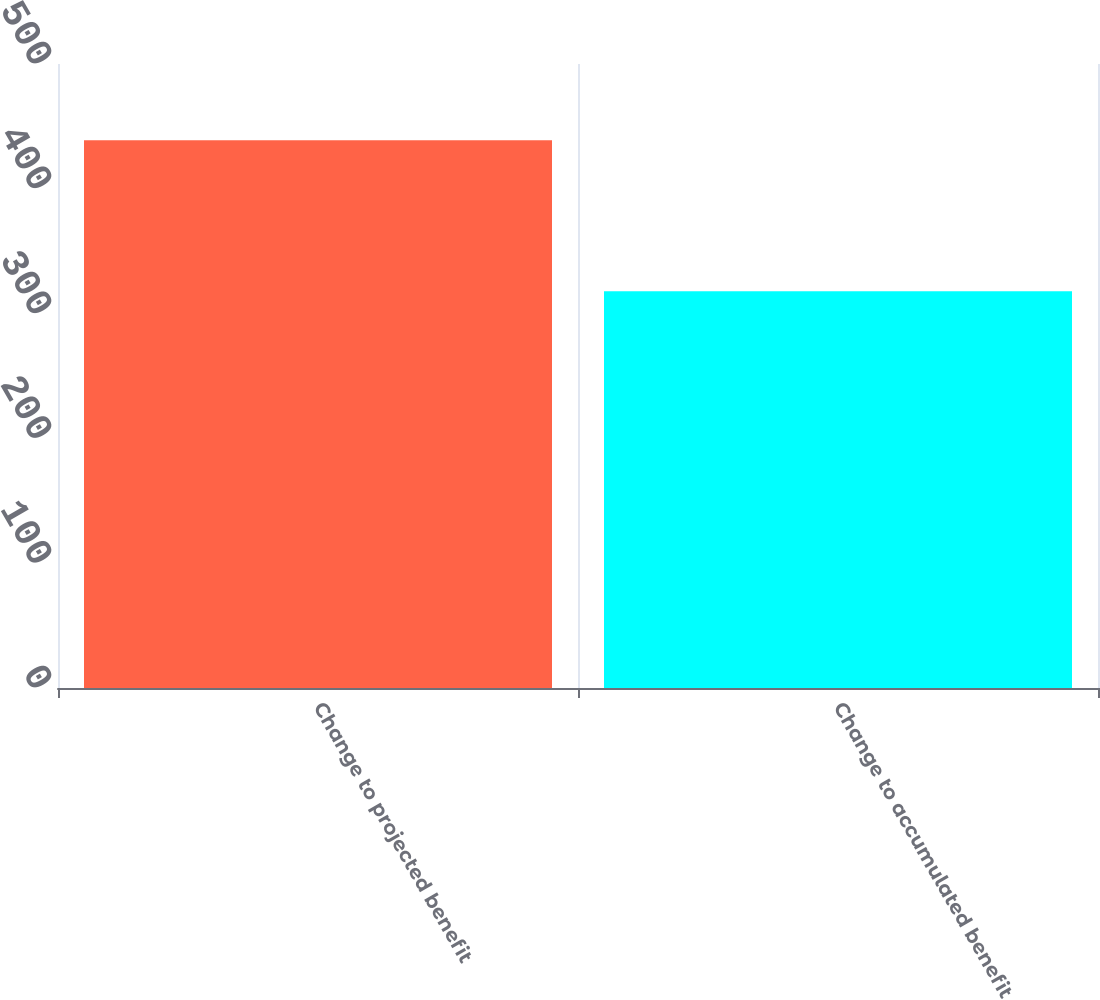<chart> <loc_0><loc_0><loc_500><loc_500><bar_chart><fcel>Change to projected benefit<fcel>Change to accumulated benefit<nl><fcel>439<fcel>318<nl></chart> 